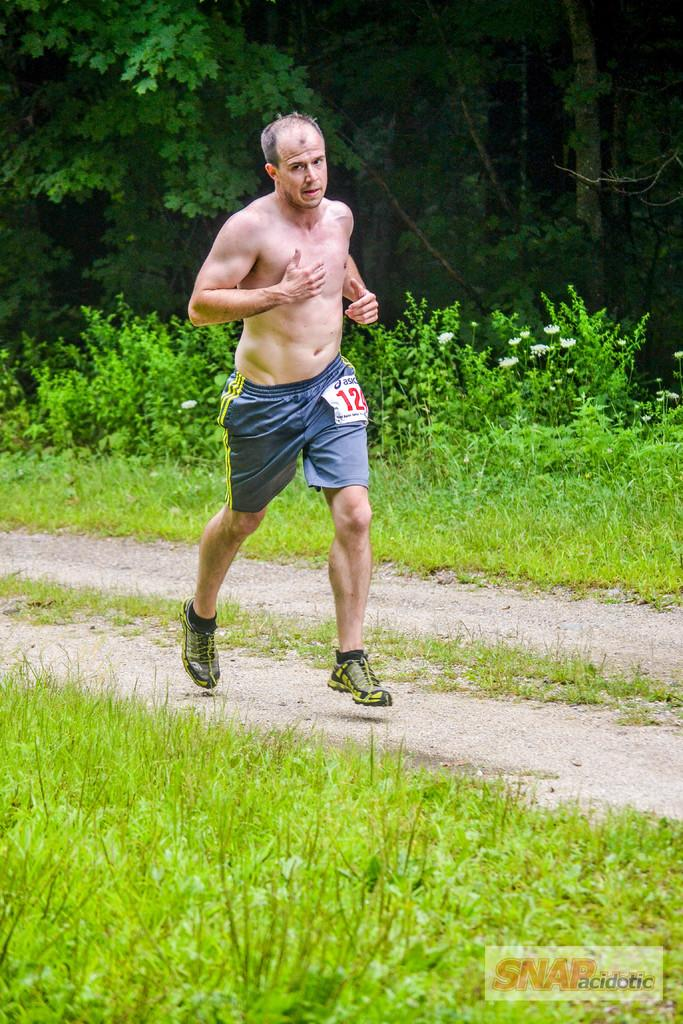<image>
Describe the image concisely. a person with shorts that say the number 12 on them 